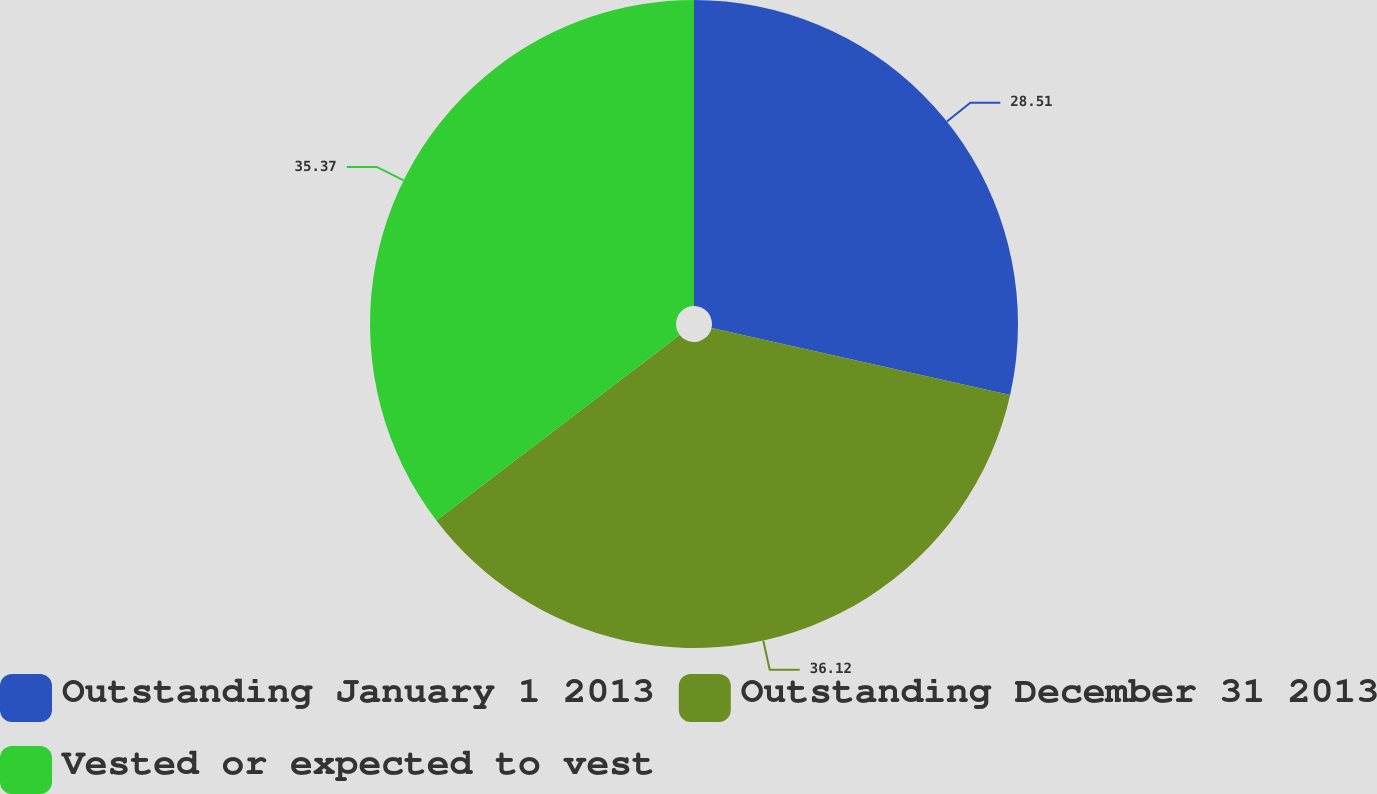<chart> <loc_0><loc_0><loc_500><loc_500><pie_chart><fcel>Outstanding January 1 2013<fcel>Outstanding December 31 2013<fcel>Vested or expected to vest<nl><fcel>28.51%<fcel>36.12%<fcel>35.37%<nl></chart> 